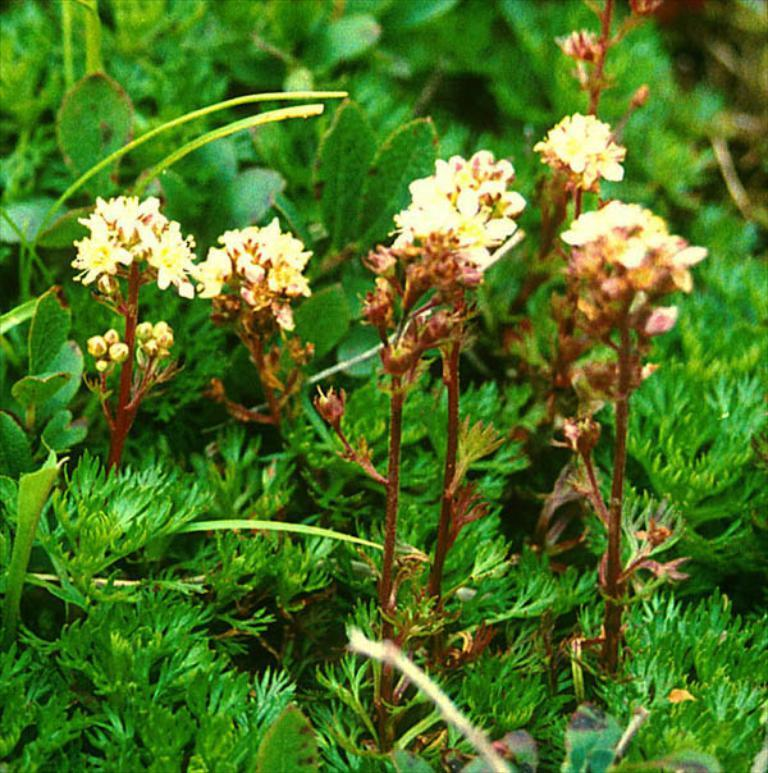What type of living organisms can be seen in the image? Plants can be seen in the image. What color are the flowers on the plants? The flowers on the plants are yellow. What stage of growth can be observed on the plants? There are buds on the plants. What color are the leaves at the bottom of the image? The leaves at the bottom of the image are green. What type of detail can be seen on the border of the image? There is no border present in the image, so it is not possible to determine what type of detail might be seen on it. 